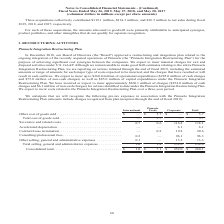According to Conagra Brands's financial document, What did the Board of Directors approve in December 2018?  a restructuring and integration plan related to the ongoing integration of the recently acquired operations of Pinnacle (the "Pinnacle Integration Restructuring Plan") for the purpose of achieving significant cost synergies between the companies. The document states: "18, our Board of Directors (the "Board") approved a restructuring and integration plan related to the ongoing integration of the recently acquired ope..." Also, What are the expected expenditures for both operational and capital under the Pinnacle Integration Restructuring Plan respectively?  The document shows two values: $360.0 million and $85.0 million. From the document: "and $75.0 million of non-cash charges) as well as $85.0 million of capital expenditures under the Pinnacle Integration Restructuring Plan. We have inc..." Also, What are the consolidated total pre-tax expenses in International and Corporate segments, respectively?  The document shows two values: $1.0 and $252.0 (in millions). From the document: "al selling, general and administrative expenses . 1.0 1.4 252.0 254.4 ng, general and administrative expenses . 1.0 1.4 252.0 254.4..." Additionally, Which segment has the highest total selling, general and administrative expenses? According to the financial document, Corporate. The relevant text states: "Foods Corporate Total..." Also, can you calculate: What is the ratio of consolidated total pre-tax expenses in Pinnacle Foods to the one in Corporate? Based on the calculation: 7.1/252.0, the result is 0.03. This is based on the information: "Consolidated total. . $ 1.0 $ 7.1 $ 252.0 $ 260.1 ng, general and administrative expenses . 1.0 1.4 252.0 254.4..." The key data points involved are: 252.0, 7.1. Also, can you calculate: What is the proportion of total accelerated depreciation expense and total contract/lease termination expense over total consolidated pre-tax expenses in all segments? To answer this question, I need to perform calculations using the financial data. The calculation is: (6.1+20.6)/260.1 , which equals 0.1. This is based on the information: "Contract/lease termination. . — 0.8 19.8 20.6 e have incurred or expect to incur approximately $260.1 million of charges ($254.0 million of cash charges and $6.1 million of non-cash charges) for actio..." The key data points involved are: 20.6, 260.1, 6.1. 